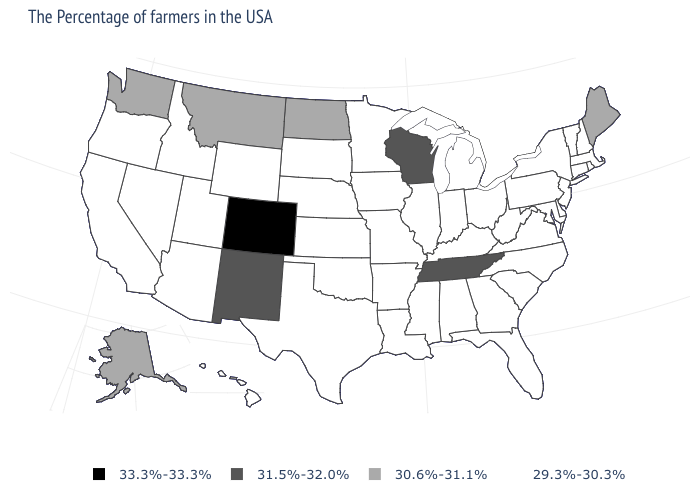Among the states that border Maine , which have the lowest value?
Short answer required. New Hampshire. Does South Carolina have a lower value than Colorado?
Write a very short answer. Yes. What is the value of Wyoming?
Be succinct. 29.3%-30.3%. Name the states that have a value in the range 29.3%-30.3%?
Write a very short answer. Massachusetts, Rhode Island, New Hampshire, Vermont, Connecticut, New York, New Jersey, Delaware, Maryland, Pennsylvania, Virginia, North Carolina, South Carolina, West Virginia, Ohio, Florida, Georgia, Michigan, Kentucky, Indiana, Alabama, Illinois, Mississippi, Louisiana, Missouri, Arkansas, Minnesota, Iowa, Kansas, Nebraska, Oklahoma, Texas, South Dakota, Wyoming, Utah, Arizona, Idaho, Nevada, California, Oregon, Hawaii. Which states have the lowest value in the Northeast?
Write a very short answer. Massachusetts, Rhode Island, New Hampshire, Vermont, Connecticut, New York, New Jersey, Pennsylvania. What is the highest value in the South ?
Concise answer only. 31.5%-32.0%. Name the states that have a value in the range 31.5%-32.0%?
Be succinct. Tennessee, Wisconsin, New Mexico. What is the highest value in states that border Idaho?
Quick response, please. 30.6%-31.1%. Name the states that have a value in the range 31.5%-32.0%?
Be succinct. Tennessee, Wisconsin, New Mexico. What is the value of Washington?
Short answer required. 30.6%-31.1%. Does Connecticut have a higher value than Oregon?
Keep it brief. No. Does the first symbol in the legend represent the smallest category?
Give a very brief answer. No. Name the states that have a value in the range 31.5%-32.0%?
Answer briefly. Tennessee, Wisconsin, New Mexico. 